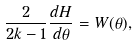<formula> <loc_0><loc_0><loc_500><loc_500>\frac { 2 } { 2 k - 1 } \frac { d H } { d \theta } = W ( \theta ) ,</formula> 